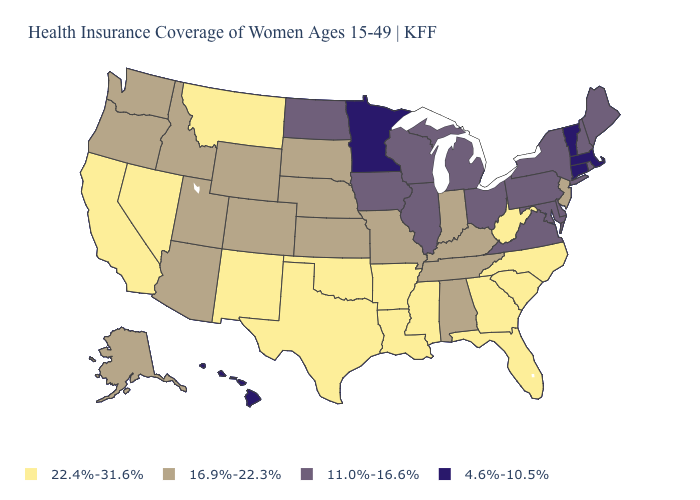Name the states that have a value in the range 16.9%-22.3%?
Give a very brief answer. Alabama, Alaska, Arizona, Colorado, Idaho, Indiana, Kansas, Kentucky, Missouri, Nebraska, New Jersey, Oregon, South Dakota, Tennessee, Utah, Washington, Wyoming. What is the value of New Hampshire?
Quick response, please. 11.0%-16.6%. Does the map have missing data?
Answer briefly. No. What is the value of Oregon?
Quick response, please. 16.9%-22.3%. Among the states that border Maryland , which have the highest value?
Give a very brief answer. West Virginia. Name the states that have a value in the range 16.9%-22.3%?
Answer briefly. Alabama, Alaska, Arizona, Colorado, Idaho, Indiana, Kansas, Kentucky, Missouri, Nebraska, New Jersey, Oregon, South Dakota, Tennessee, Utah, Washington, Wyoming. Does Kentucky have the lowest value in the USA?
Keep it brief. No. What is the value of California?
Answer briefly. 22.4%-31.6%. What is the value of Connecticut?
Concise answer only. 4.6%-10.5%. Name the states that have a value in the range 16.9%-22.3%?
Write a very short answer. Alabama, Alaska, Arizona, Colorado, Idaho, Indiana, Kansas, Kentucky, Missouri, Nebraska, New Jersey, Oregon, South Dakota, Tennessee, Utah, Washington, Wyoming. What is the value of Rhode Island?
Concise answer only. 11.0%-16.6%. Which states have the lowest value in the USA?
Answer briefly. Connecticut, Hawaii, Massachusetts, Minnesota, Vermont. How many symbols are there in the legend?
Keep it brief. 4. Does Connecticut have the lowest value in the Northeast?
Concise answer only. Yes. 